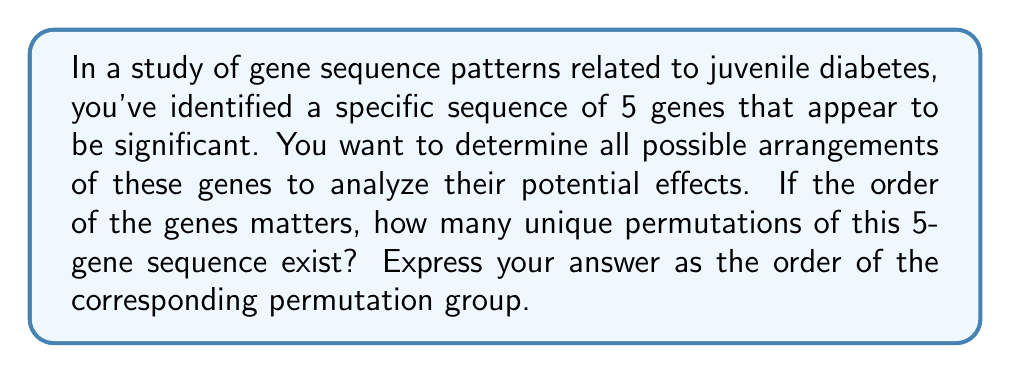Give your solution to this math problem. To solve this problem, we need to understand the concept of permutation groups in the context of gene sequences:

1) In this case, we have 5 distinct genes, and we're considering all possible arrangements where the order matters.

2) This scenario corresponds to the symmetric group $S_5$, which is the group of all permutations of 5 elements.

3) The order of a permutation group is the number of elements (permutations) in the group.

4) For a set of $n$ distinct elements, the number of permutations is given by $n!$ (n factorial).

5) In this case, $n = 5$, so we need to calculate $5!$:

   $$5! = 5 \times 4 \times 3 \times 2 \times 1 = 120$$

6) Therefore, the order of the permutation group $S_5$ is 120.

This means there are 120 unique ways to arrange the 5 genes in the sequence, each of which could potentially have different effects on juvenile diabetes expression or treatment response.
Answer: The order of the permutation group for the 5-gene sequence is 120. 